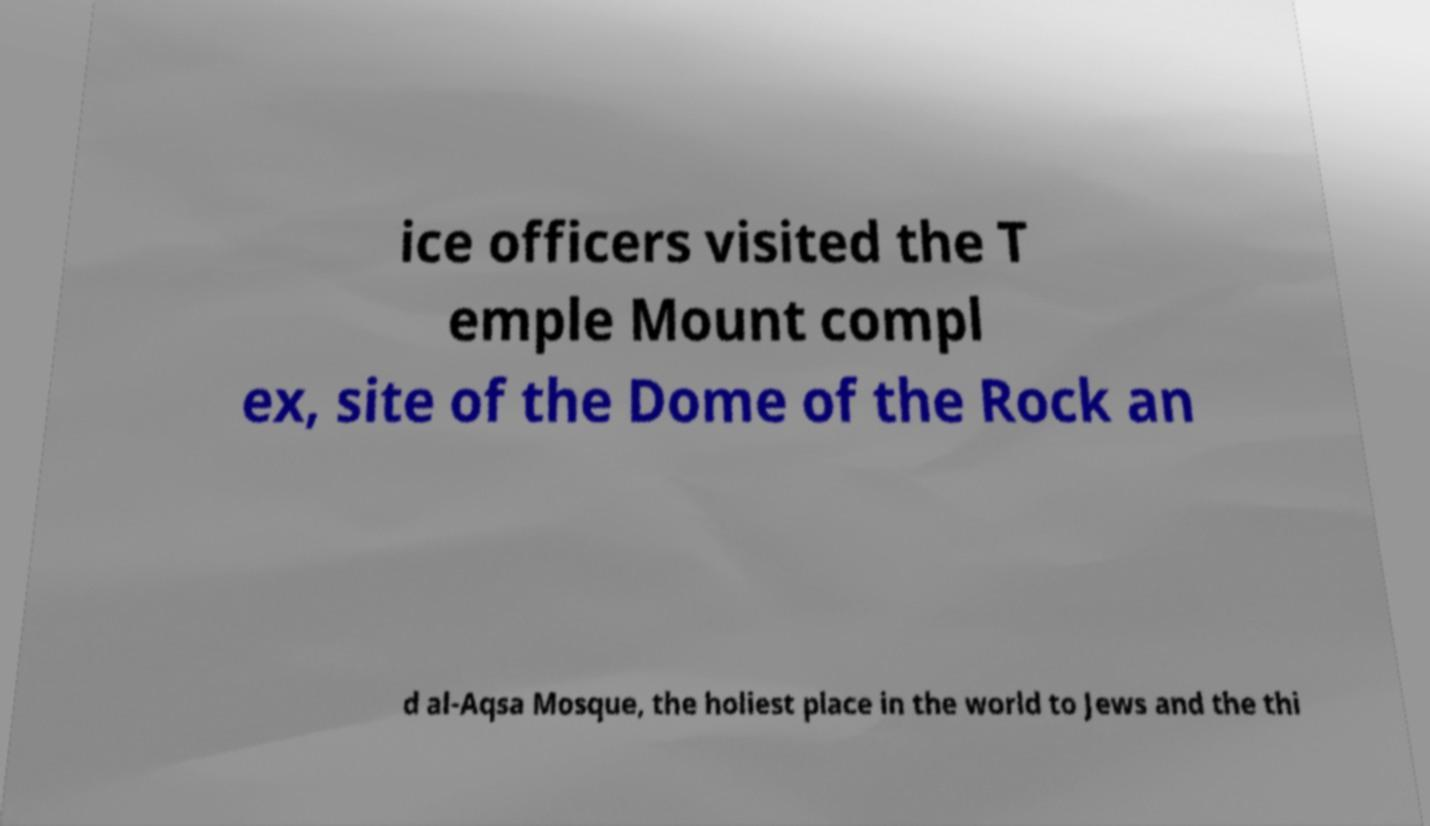Please identify and transcribe the text found in this image. ice officers visited the T emple Mount compl ex, site of the Dome of the Rock an d al-Aqsa Mosque, the holiest place in the world to Jews and the thi 